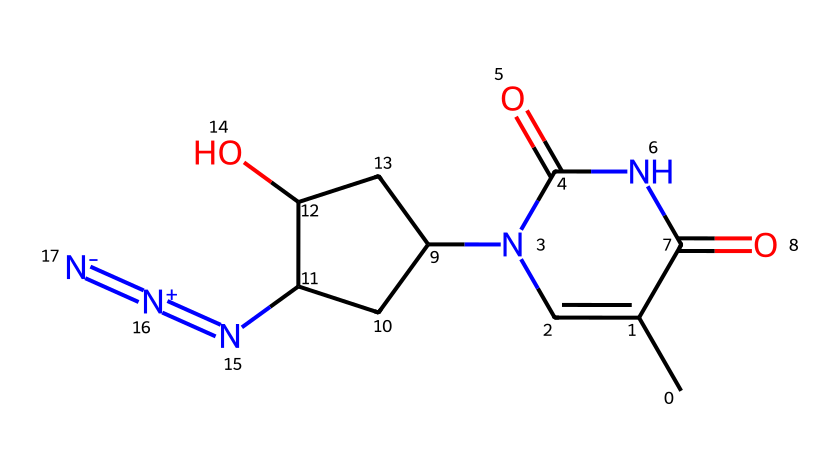What is the total number of nitrogen atoms in azidothymidine? In the SMILES representation, each nitrogen atom can be identified. There are three nitrogen atoms present: numbered within the N in the chain and in the azide functional group (=N+N-).
Answer: three How many rings are present in the chemical structure of azidothymidine? Examining the structural representation, there is one five-membered ring (the pyrimidine ring) visible in the SMILES, as indicated by the initial "C1" and its connections.
Answer: one What functional group characterizes azidothymidine? The distinctive azide functional group can be identified by the "N=[N+]=[N-]" portion of the SMILES, indicating the presence of multiple nitrogen atoms bonded together. This is characteristic of azides.
Answer: azide How many oxygen atoms are present in this molecule? In the SMILES representation, we can observe the two occurrences of "O" which indicate that there are two oxygen atoms overall within the structure of azidothymidine.
Answer: two What type of bond connects the nitrogen atoms in the azide group? The bonds connecting the nitrogen in the azide group are double bonds, as denoted by the "=N" and the "[N+]=[N-]" symbols in the SMILES. These indicate a connectivity of nitrogen atoms via double bonds.
Answer: double Which part of the molecule is responsible for its antiviral activity? The azide group is known to interfere with viral replication and is responsible for AZT's antiviral action, given the chemical's role in HIV treatment, which also extends to treating feline immunodeficiency virus.
Answer: azide group 